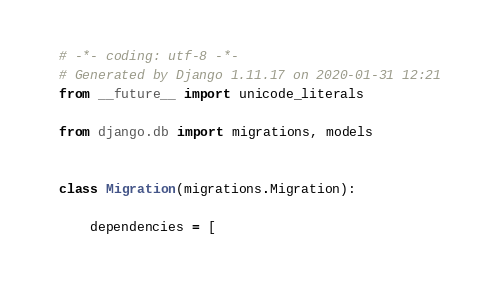Convert code to text. <code><loc_0><loc_0><loc_500><loc_500><_Python_># -*- coding: utf-8 -*-
# Generated by Django 1.11.17 on 2020-01-31 12:21
from __future__ import unicode_literals

from django.db import migrations, models


class Migration(migrations.Migration):

    dependencies = [</code> 